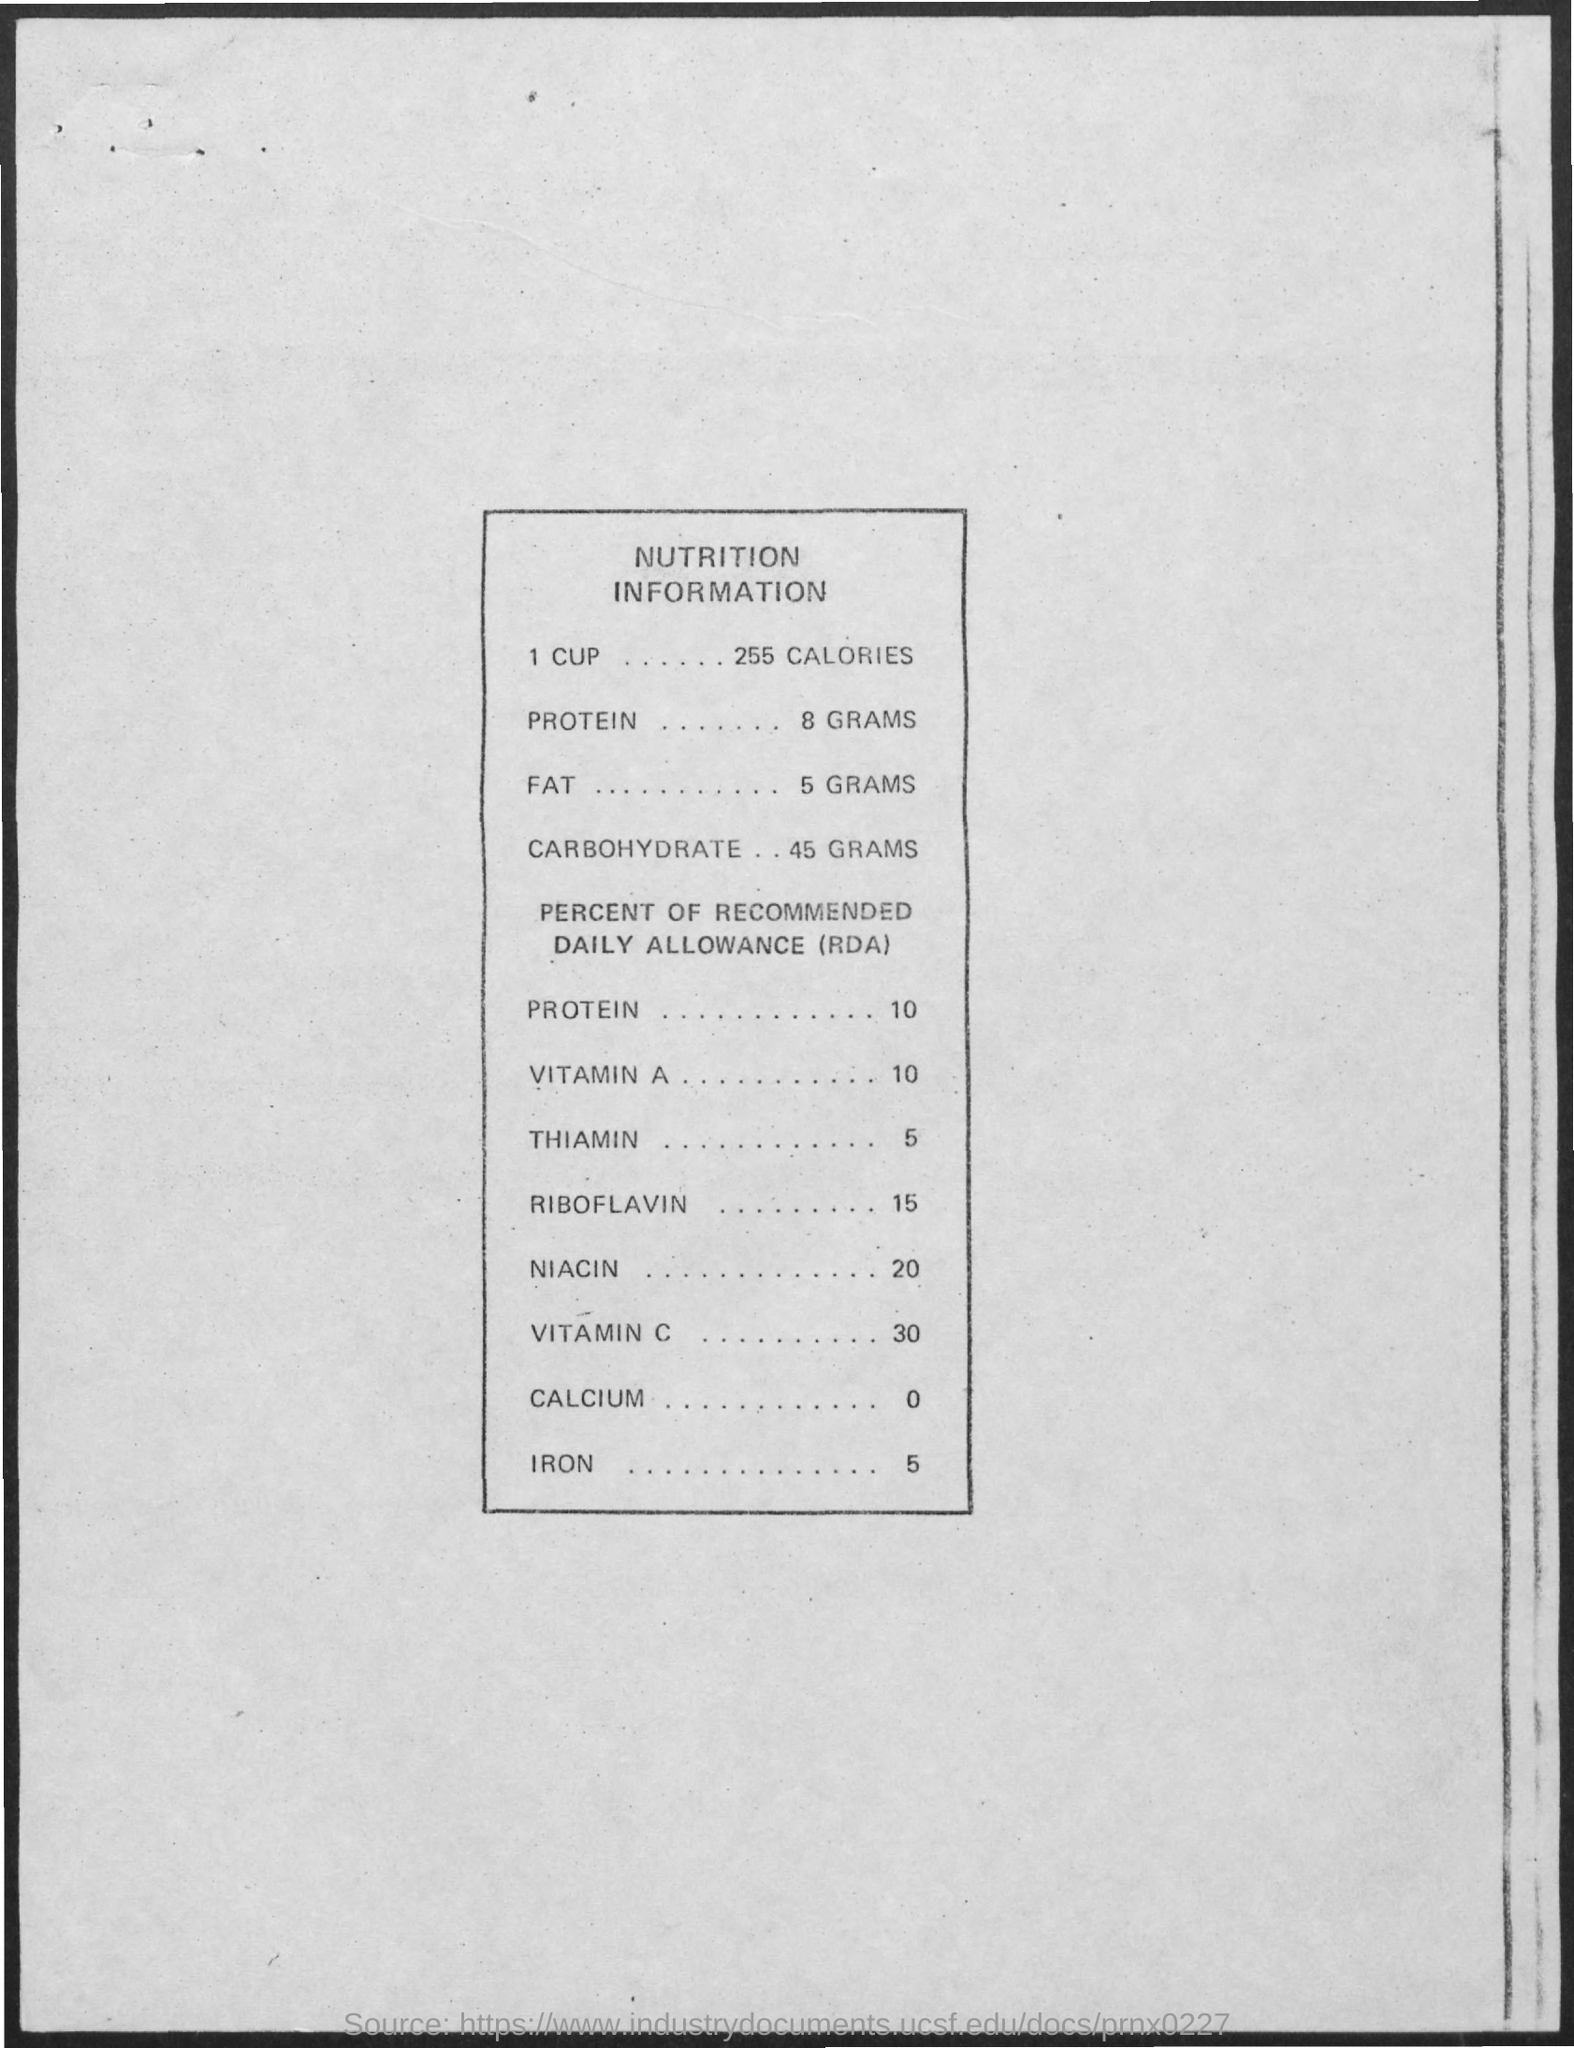What  is the information mentioned in the given page ?
Keep it short and to the point. Nutrition information. How many calories will be equals to 1 cup ?
Your answer should be very brief. 255 calories. How many grams will be equals to protein ?
Keep it short and to the point. 8. How many grams will be equals to carbohydrate ?
Keep it short and to the point. 45 grams. How much percent of protein is recommended for daily allowance ?
Your response must be concise. 10. How much percent of thiamin is needed for daily allowance ?
Make the answer very short. 5. How much percent of vitamin c is needed for daily allowance ?
Make the answer very short. 30. How much percent of vitamin a is needed for rda ?
Provide a short and direct response. 10. How much percent of riboflavin is needed for rda?
Give a very brief answer. 15. How much percentage of niacin is needed for rda ?
Offer a terse response. 20. 